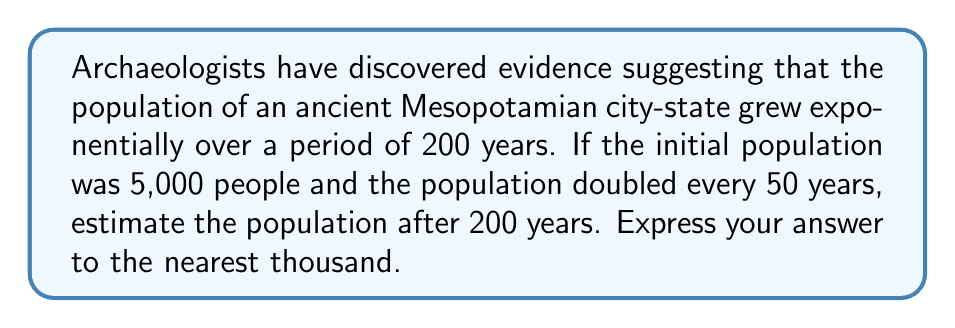Give your solution to this math problem. To solve this problem, we'll use the exponential growth equation:

$$P(t) = P_0 \cdot (1 + r)^t$$

Where:
$P(t)$ is the population at time $t$
$P_0$ is the initial population
$r$ is the growth rate
$t$ is the time period

Given information:
- Initial population $(P_0) = 5,000$
- Population doubles every 50 years
- Total time period $(t) = 200$ years

Step 1: Calculate the growth rate $(r)$
The population doubles every 50 years, so we can set up the equation:
$$5,000 \cdot (1 + r)^{50} = 10,000$$

Simplifying:
$$(1 + r)^{50} = 2$$

Taking the 50th root of both sides:
$$1 + r = 2^{\frac{1}{50}} \approx 1.014$$

Therefore, $r \approx 0.014$ or 1.4% per year

Step 2: Use the exponential growth equation to calculate the population after 200 years
$$P(200) = 5,000 \cdot (1 + 0.014)^{200}$$

Step 3: Calculate the result
$$P(200) = 5,000 \cdot (1.014)^{200} \approx 40,388$$

Step 4: Round to the nearest thousand
40,388 rounds to 40,000
Answer: 40,000 people 